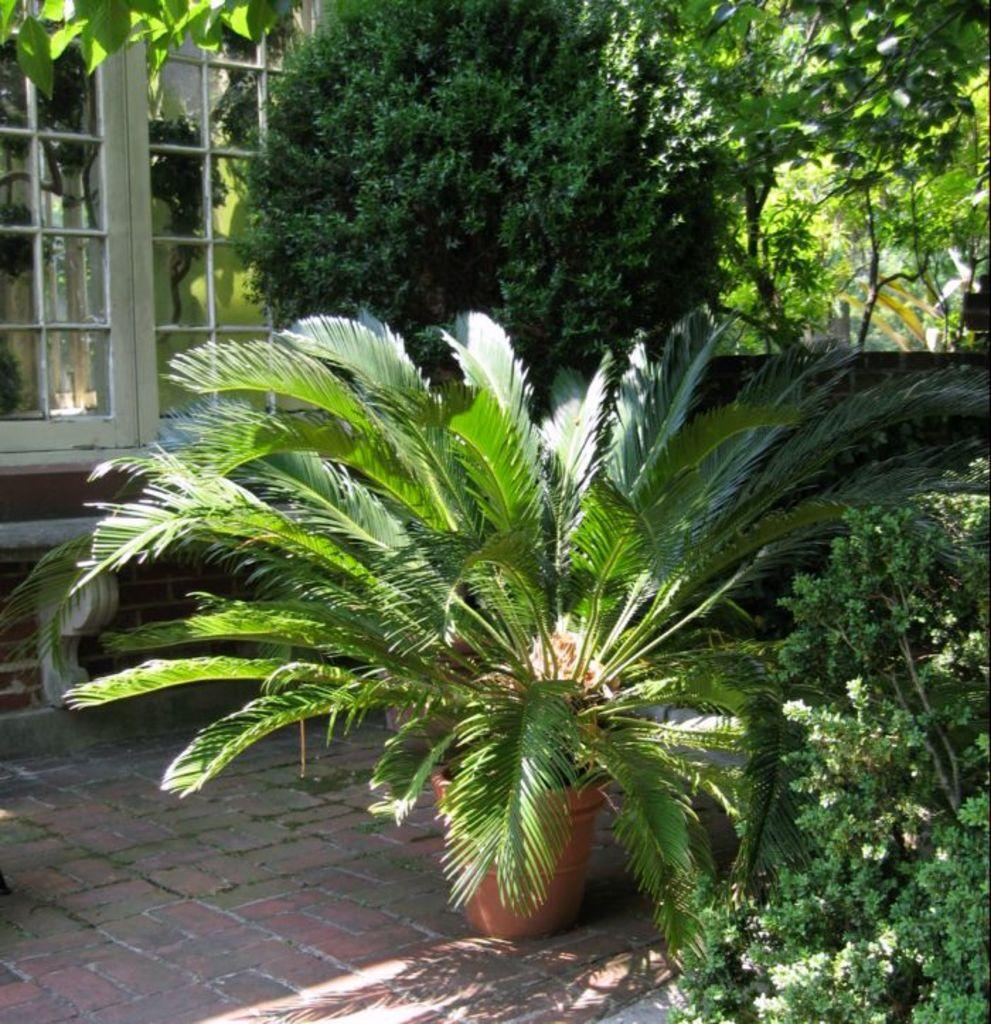What type of vegetation can be seen in the image? There are plants and trees in the image. What is the man-made structure visible in the image? There is a wall in the image. What type of architectural feature is present in the image? There is a glass window in the image. What type of wire can be seen hanging from the trees in the image? There is no wire visible in the image; only plants, trees, a wall, and a glass window are present. 